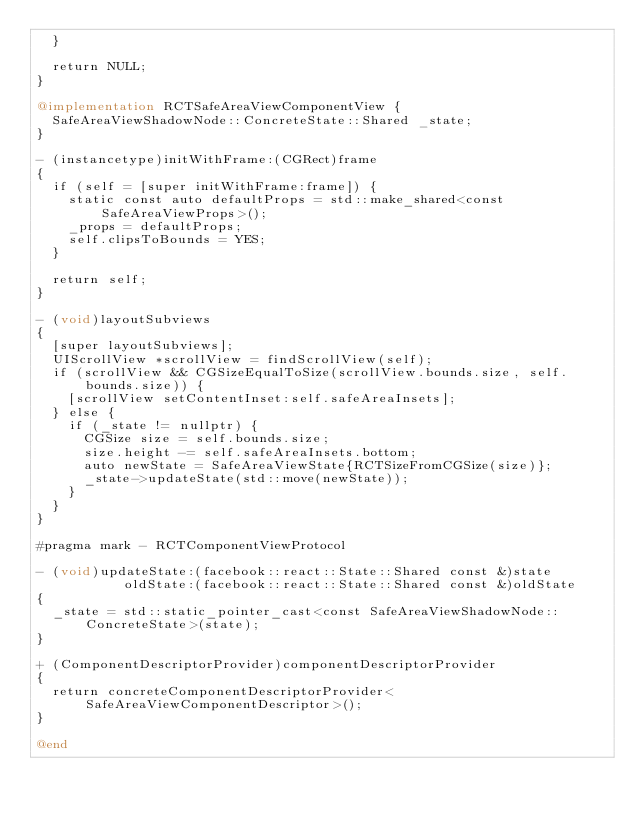<code> <loc_0><loc_0><loc_500><loc_500><_ObjectiveC_>  }

  return NULL;
}

@implementation RCTSafeAreaViewComponentView {
  SafeAreaViewShadowNode::ConcreteState::Shared _state;
}

- (instancetype)initWithFrame:(CGRect)frame
{
  if (self = [super initWithFrame:frame]) {
    static const auto defaultProps = std::make_shared<const SafeAreaViewProps>();
    _props = defaultProps;
    self.clipsToBounds = YES;
  }

  return self;
}

- (void)layoutSubviews
{
  [super layoutSubviews];
  UIScrollView *scrollView = findScrollView(self);
  if (scrollView && CGSizeEqualToSize(scrollView.bounds.size, self.bounds.size)) {
    [scrollView setContentInset:self.safeAreaInsets];
  } else {
    if (_state != nullptr) {
      CGSize size = self.bounds.size;
      size.height -= self.safeAreaInsets.bottom;
      auto newState = SafeAreaViewState{RCTSizeFromCGSize(size)};
      _state->updateState(std::move(newState));
    }
  }
}

#pragma mark - RCTComponentViewProtocol

- (void)updateState:(facebook::react::State::Shared const &)state
           oldState:(facebook::react::State::Shared const &)oldState
{
  _state = std::static_pointer_cast<const SafeAreaViewShadowNode::ConcreteState>(state);
}

+ (ComponentDescriptorProvider)componentDescriptorProvider
{
  return concreteComponentDescriptorProvider<SafeAreaViewComponentDescriptor>();
}

@end
</code> 